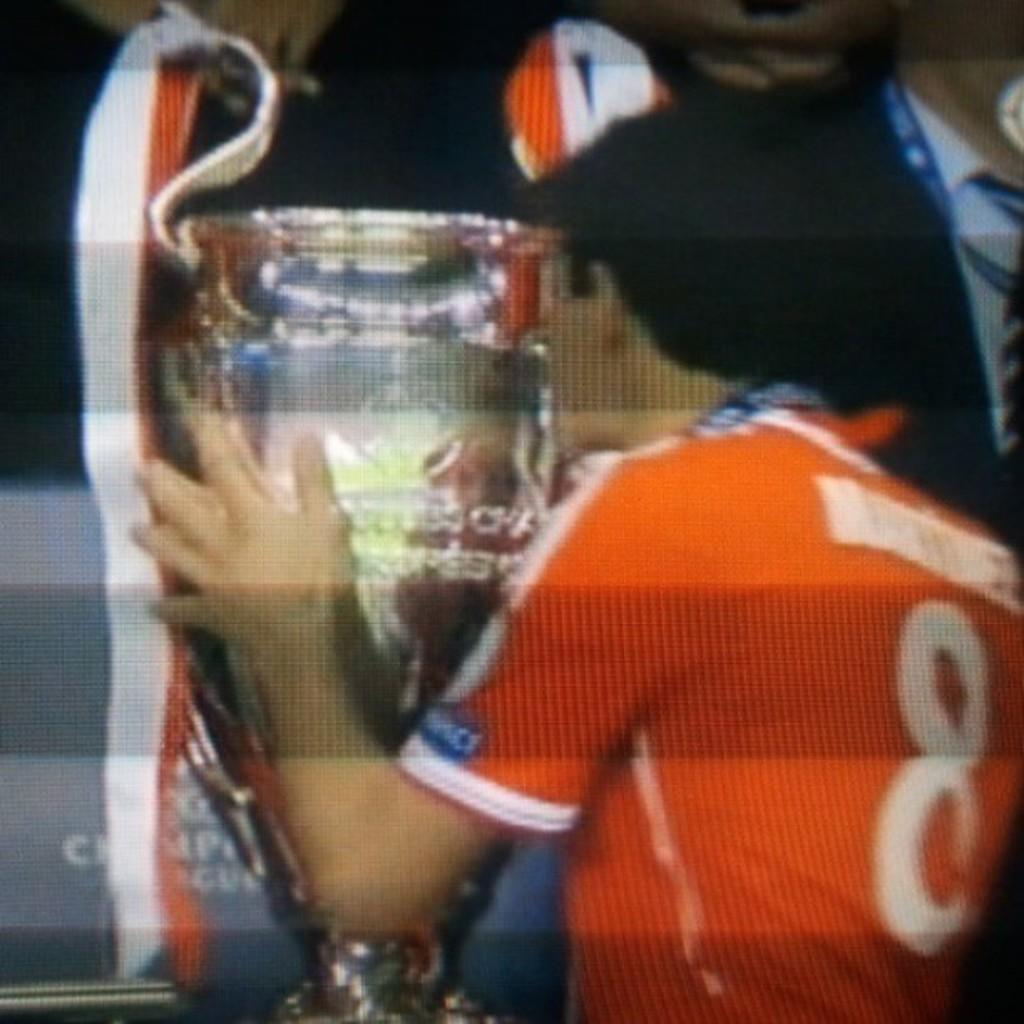<image>
Describe the image concisely. A player wearing a number 8 orange shirt kisses an oversized trophy. 